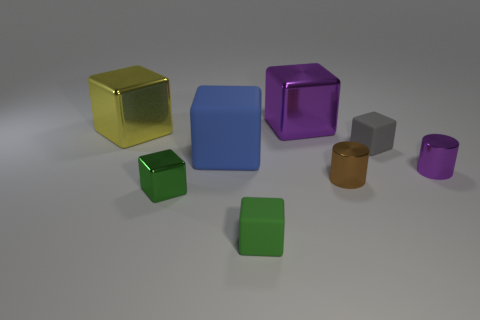Subtract all large blue cubes. How many cubes are left? 5 Subtract 1 blocks. How many blocks are left? 5 Add 2 large things. How many objects exist? 10 Subtract all green blocks. How many blocks are left? 4 Add 1 gray rubber cubes. How many gray rubber cubes are left? 2 Add 6 blue rubber objects. How many blue rubber objects exist? 7 Subtract 0 green spheres. How many objects are left? 8 Subtract all cubes. How many objects are left? 2 Subtract all purple cylinders. Subtract all yellow balls. How many cylinders are left? 1 Subtract all yellow cylinders. How many brown blocks are left? 0 